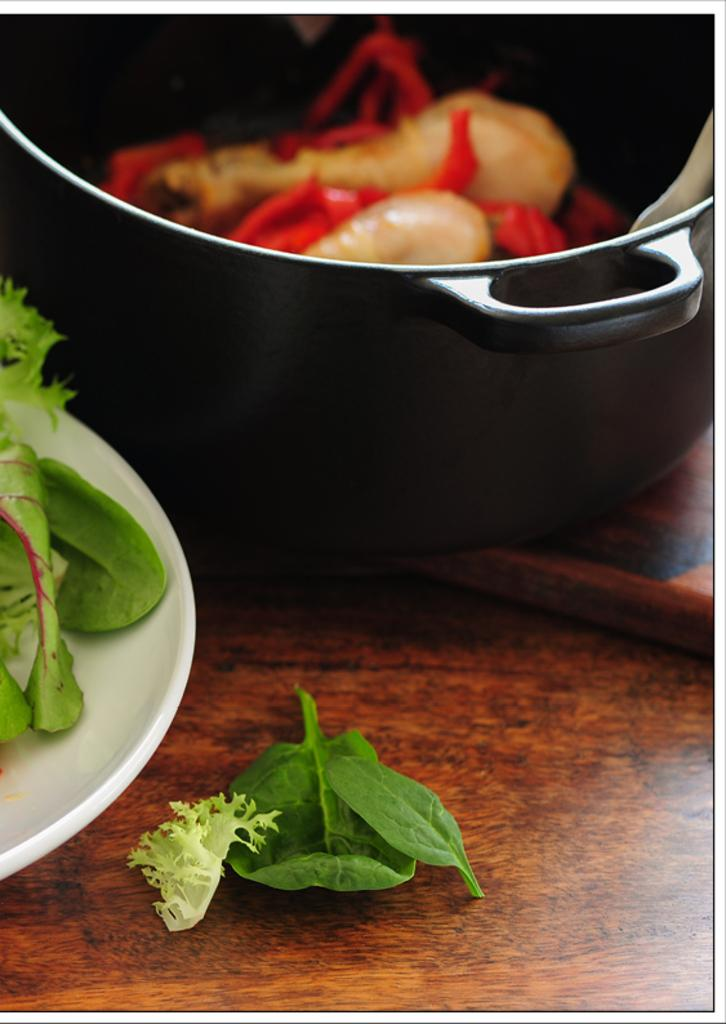What is located on the left side of the image? There is a plate on the left side of the image. What is at the top of the image? There is a bowl at the top of the image. What type of food is on the plate? The plate contains leafy vegetables. What is in the bowl? The bowl contains eatables. What type of coat is hanging on the wall in the image? There is no coat present in the image; it only features a plate with leafy vegetables and a bowl with eatables. How much debt is visible in the image? There is no mention of debt in the image; it focuses on food items. 